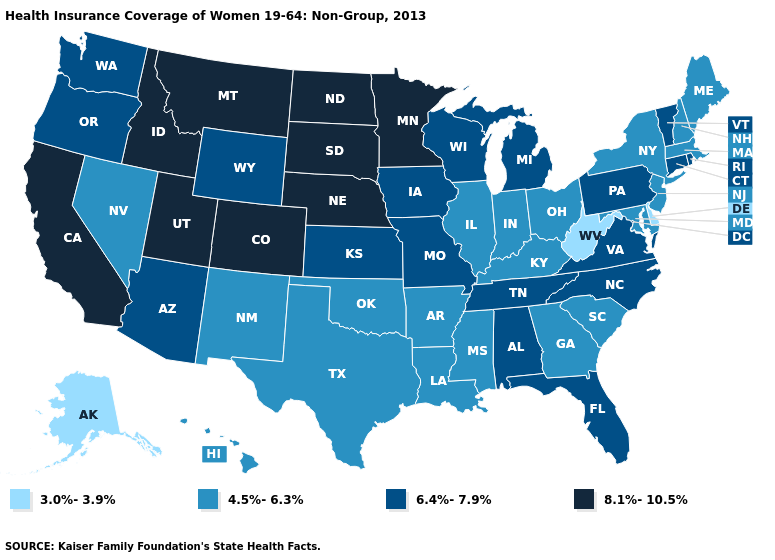What is the value of Kansas?
Give a very brief answer. 6.4%-7.9%. Name the states that have a value in the range 4.5%-6.3%?
Keep it brief. Arkansas, Georgia, Hawaii, Illinois, Indiana, Kentucky, Louisiana, Maine, Maryland, Massachusetts, Mississippi, Nevada, New Hampshire, New Jersey, New Mexico, New York, Ohio, Oklahoma, South Carolina, Texas. What is the value of Alaska?
Write a very short answer. 3.0%-3.9%. Does Washington have a lower value than Idaho?
Quick response, please. Yes. Does Alaska have the lowest value in the West?
Write a very short answer. Yes. Among the states that border New Mexico , does Texas have the lowest value?
Quick response, please. Yes. Does Maryland have a lower value than Nevada?
Be succinct. No. Among the states that border California , which have the highest value?
Give a very brief answer. Arizona, Oregon. Among the states that border Delaware , which have the highest value?
Concise answer only. Pennsylvania. What is the value of Massachusetts?
Give a very brief answer. 4.5%-6.3%. What is the value of Texas?
Concise answer only. 4.5%-6.3%. What is the highest value in the South ?
Give a very brief answer. 6.4%-7.9%. Does Illinois have a higher value than Delaware?
Keep it brief. Yes. Does Rhode Island have the lowest value in the Northeast?
Short answer required. No. Name the states that have a value in the range 8.1%-10.5%?
Concise answer only. California, Colorado, Idaho, Minnesota, Montana, Nebraska, North Dakota, South Dakota, Utah. 